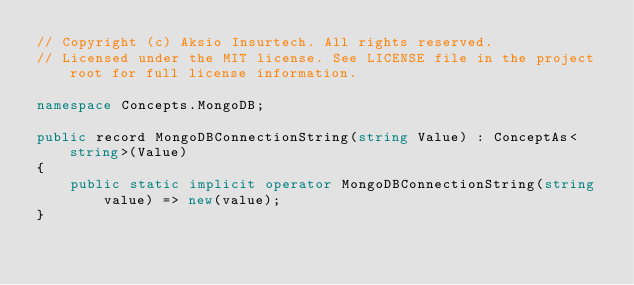<code> <loc_0><loc_0><loc_500><loc_500><_C#_>// Copyright (c) Aksio Insurtech. All rights reserved.
// Licensed under the MIT license. See LICENSE file in the project root for full license information.

namespace Concepts.MongoDB;

public record MongoDBConnectionString(string Value) : ConceptAs<string>(Value)
{
    public static implicit operator MongoDBConnectionString(string value) => new(value);
}
</code> 